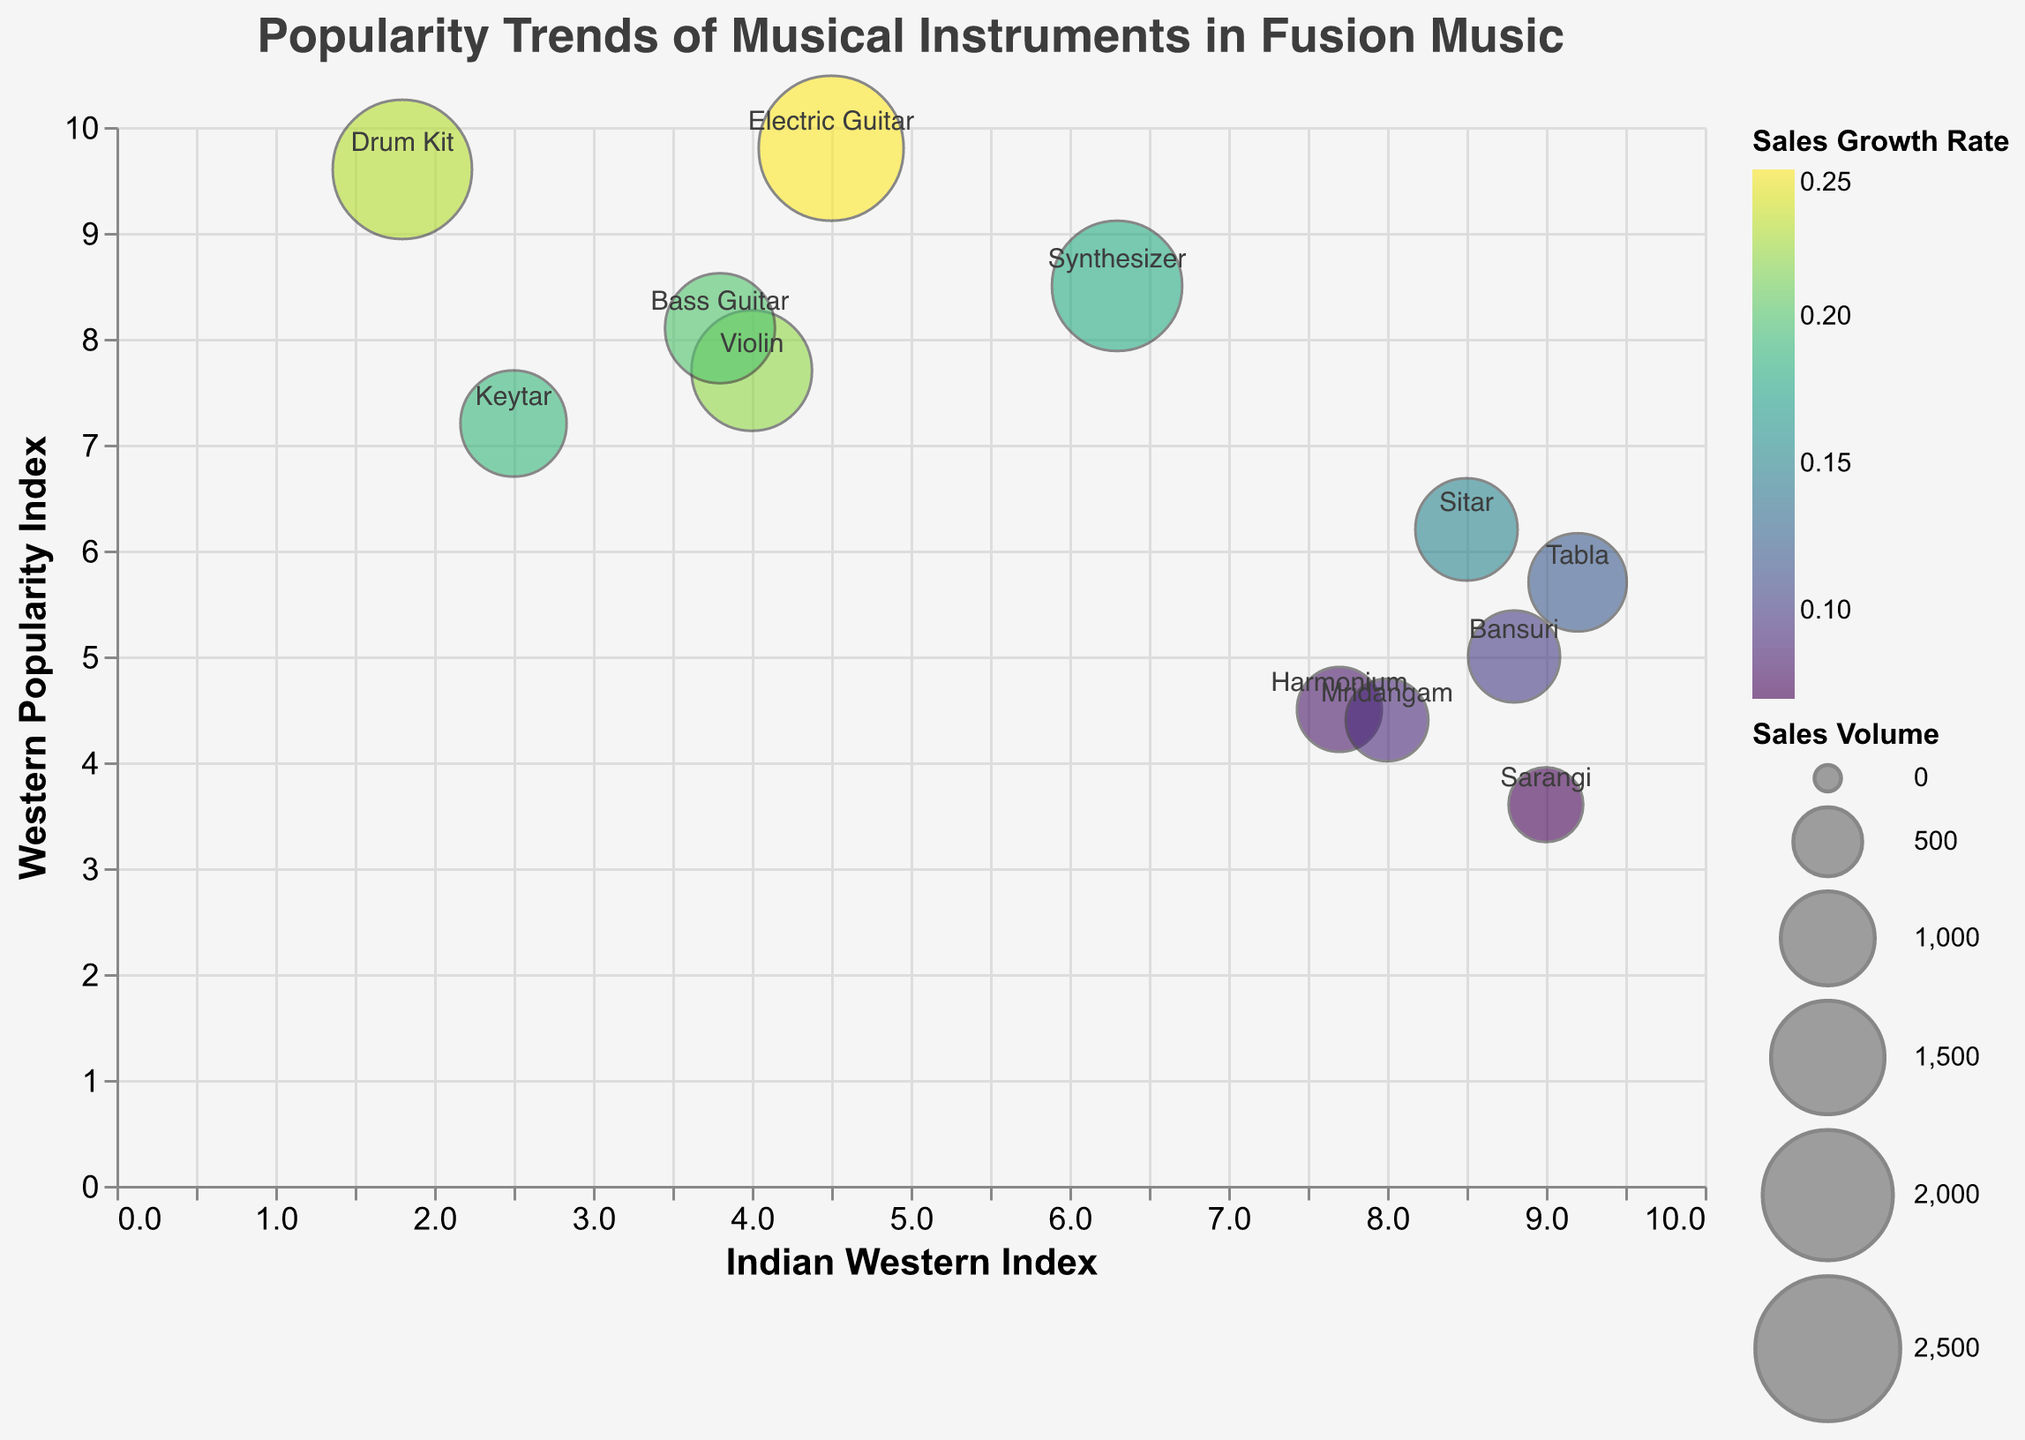What is the title of the chart? The title is located at the top of the chart.
Answer: Popularity Trends of Musical Instruments in Fusion Music How many instruments have a higher Indian Western Index than Western Popularity Index? Count the number of instruments where the Indian Western Index is greater than the Western Popularity Index. Specifically, check if the Indian Western Index value is greater for each instrument.
Answer: 7 Which instrument has the highest Sales Volume? Look at the bubble sizes and identify the largest bubble which represents the highest Sales Volume.
Answer: Electric Guitar What is the Sales Growth Rate of the instrument with the highest Western Popularity Index? Identify the instrument with the highest Western Popularity Index (9.8 for Electric Guitar) and then find its Sales Growth Rate.
Answer: 0.25 Which instrument is most balanced between Indian and Western popularity? Find the instrument whose Indian Western Index is closest to its Western Popularity Index.
Answer: Sitar Which instruments have a higher Western Popularity Index than Electric Guitar? Compare the Western Popularity Index values of all instruments and find those greater than Electric Guitar's value of 9.8.
Answer: None What is the average Sales Growth Rate of all instruments? Add up all the Sales Growth Rate values and divide by the number of instruments to get the average. Calculation: (0.15 + 0.12 + 0.25 + 0.18 + 0.22 + 0.10 + 0.20 + 0.08 + 0.23 + 0.09 + 0.07 + 0.19) / 12 = 1.88 / 12
Answer: 0.157 Which instrument has the smallest bubble? Identify the smallest bubble which represents the instrument with the lowest Sales Volume.
Answer: Sarangi What is the range of the Indian Western Index for the data points? Find the minimum and maximum values of the Indian Western Index and calculate the range. Min is 1.8 (Drum Kit) and Max is 9.2 (Tabla). Range is 9.2 - 1.8.
Answer: 7.4 Which instrument has the highest Sales Growth Rate and what is its Sales Volume? Identify the instrument with the highest 'Sales Growth Rate' value (0.25 for Electric Guitar) and get its 'Sales Volume'.
Answer: 2500 